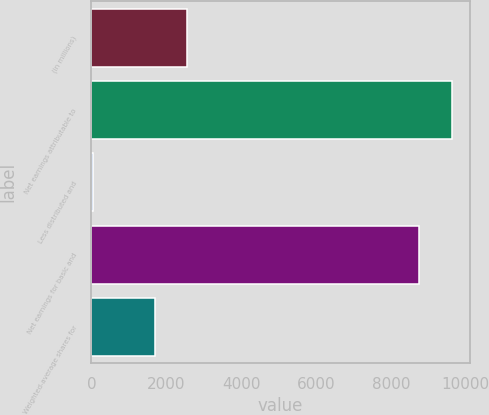<chart> <loc_0><loc_0><loc_500><loc_500><bar_chart><fcel>(in millions)<fcel>Net earnings attributable to<fcel>Less distributed and<fcel>Net earnings for basic and<fcel>Weighted-average shares for<nl><fcel>2567.2<fcel>9627.2<fcel>48<fcel>8752<fcel>1692<nl></chart> 